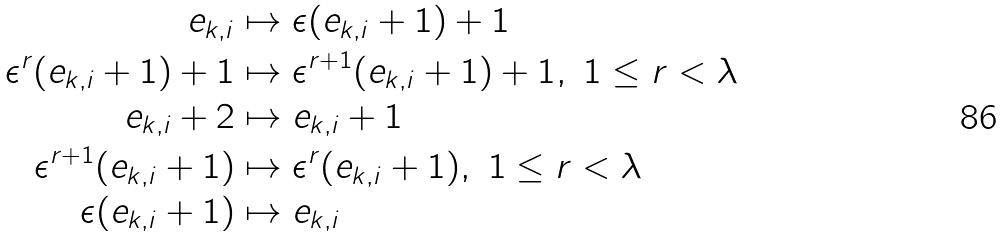<formula> <loc_0><loc_0><loc_500><loc_500>e _ { k , i } & \mapsto \epsilon ( e _ { k , i } + 1 ) + 1 \\ \epsilon ^ { r } ( e _ { k , i } + 1 ) + 1 & \mapsto \epsilon ^ { r + 1 } ( e _ { k , i } + 1 ) + 1 , \ 1 \leq r < \lambda \\ e _ { k , i } + 2 & \mapsto e _ { k , i } + 1 \\ \epsilon ^ { r + 1 } ( e _ { k , i } + 1 ) & \mapsto \epsilon ^ { r } ( e _ { k , i } + 1 ) , \ 1 \leq r < \lambda \\ \epsilon ( e _ { k , i } + 1 ) & \mapsto e _ { k , i } \\</formula> 